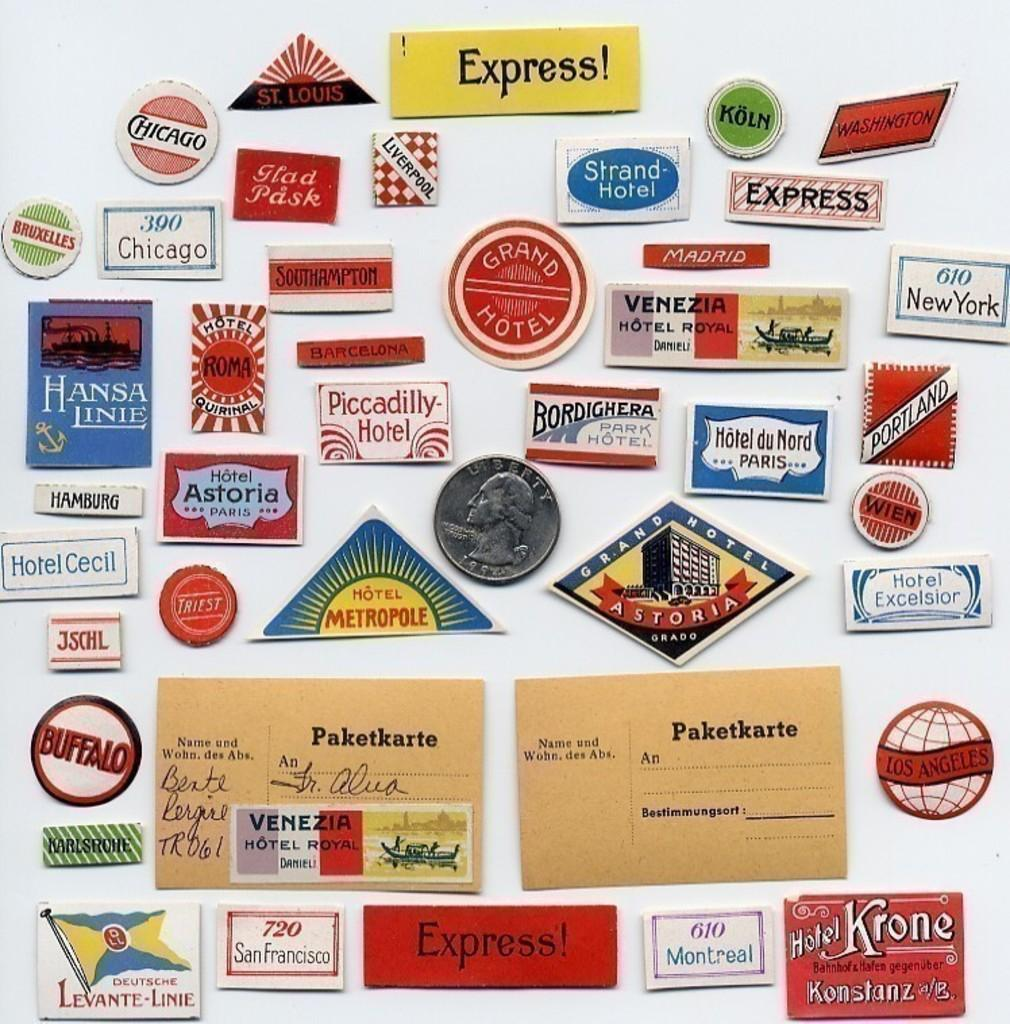<image>
Provide a brief description of the given image. A collection of gas station and hotel express magnets on a fridge. 